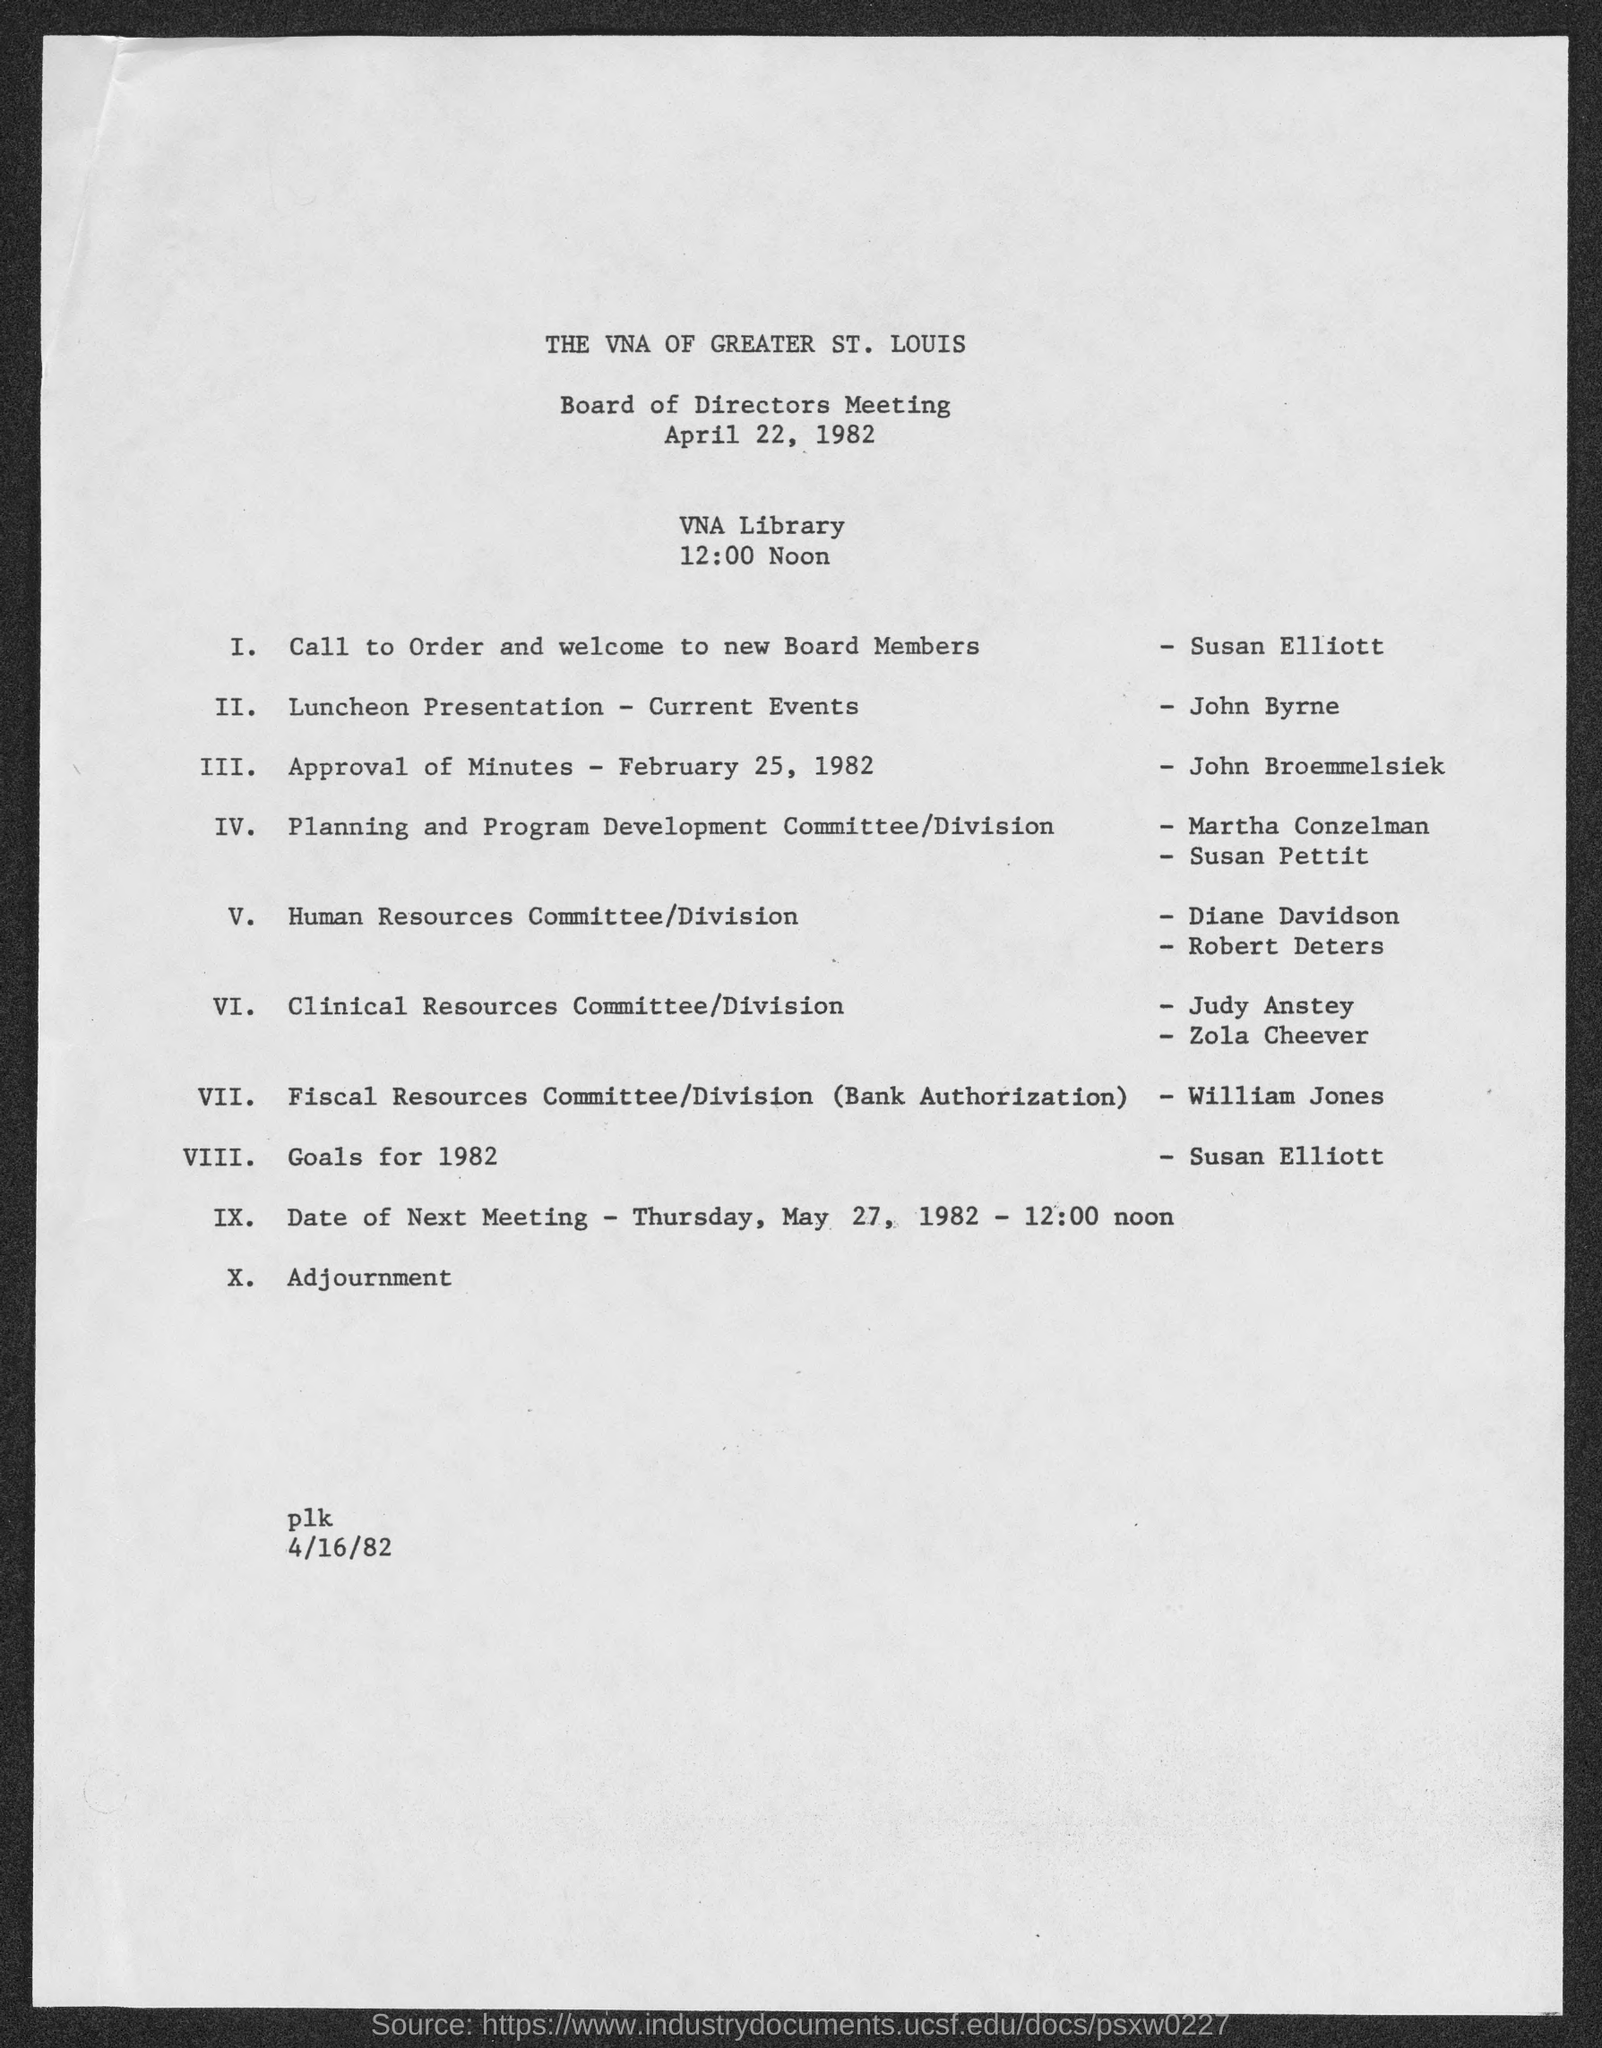When is the meeting going to be held?
Your answer should be very brief. 12:00 Noon. Where is the meeting?
Ensure brevity in your answer.  VNA library. Who is taking the Luncheon Presentation?
Make the answer very short. John Byrne. What is John Broemmelsiek's duty?
Offer a very short reply. Approval of Minutes- February 25, 1982. Who is speaking on Goals for 1982?
Make the answer very short. Susan Elliott. When is the next meeting?
Your answer should be very brief. May 27, 1982. 